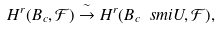<formula> <loc_0><loc_0><loc_500><loc_500>H ^ { r } ( B _ { c } , \mathcal { F } ) \stackrel { \sim } { \rightarrow } H ^ { r } ( B _ { c } \ s m i U , \mathcal { F } ) ,</formula> 